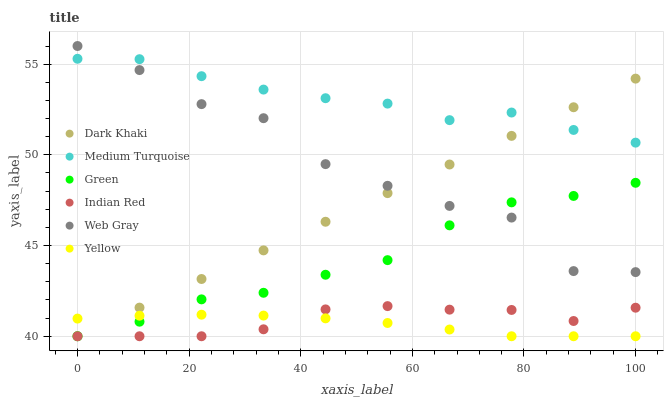Does Yellow have the minimum area under the curve?
Answer yes or no. Yes. Does Medium Turquoise have the maximum area under the curve?
Answer yes or no. Yes. Does Medium Turquoise have the minimum area under the curve?
Answer yes or no. No. Does Yellow have the maximum area under the curve?
Answer yes or no. No. Is Dark Khaki the smoothest?
Answer yes or no. Yes. Is Web Gray the roughest?
Answer yes or no. Yes. Is Medium Turquoise the smoothest?
Answer yes or no. No. Is Medium Turquoise the roughest?
Answer yes or no. No. Does Yellow have the lowest value?
Answer yes or no. Yes. Does Medium Turquoise have the lowest value?
Answer yes or no. No. Does Web Gray have the highest value?
Answer yes or no. Yes. Does Medium Turquoise have the highest value?
Answer yes or no. No. Is Indian Red less than Web Gray?
Answer yes or no. Yes. Is Medium Turquoise greater than Yellow?
Answer yes or no. Yes. Does Web Gray intersect Dark Khaki?
Answer yes or no. Yes. Is Web Gray less than Dark Khaki?
Answer yes or no. No. Is Web Gray greater than Dark Khaki?
Answer yes or no. No. Does Indian Red intersect Web Gray?
Answer yes or no. No. 